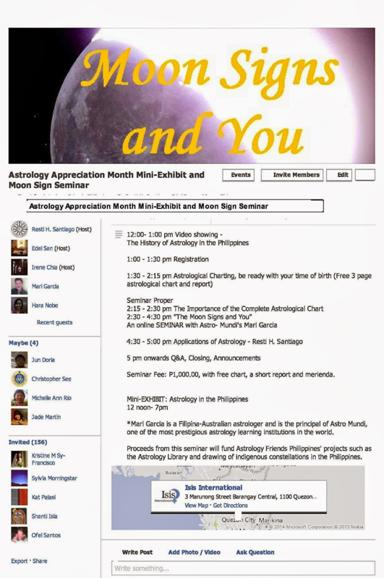How is the seminar promoting the study of indigenous constellations? The seminar actively promotes the study of indigenous constellations through its funding of projects aimed at drawing and documenting these constellations. This initiative helps preserve and enrich the astrological knowledge specific to the Philippines, integrating it with global astrological practices. 